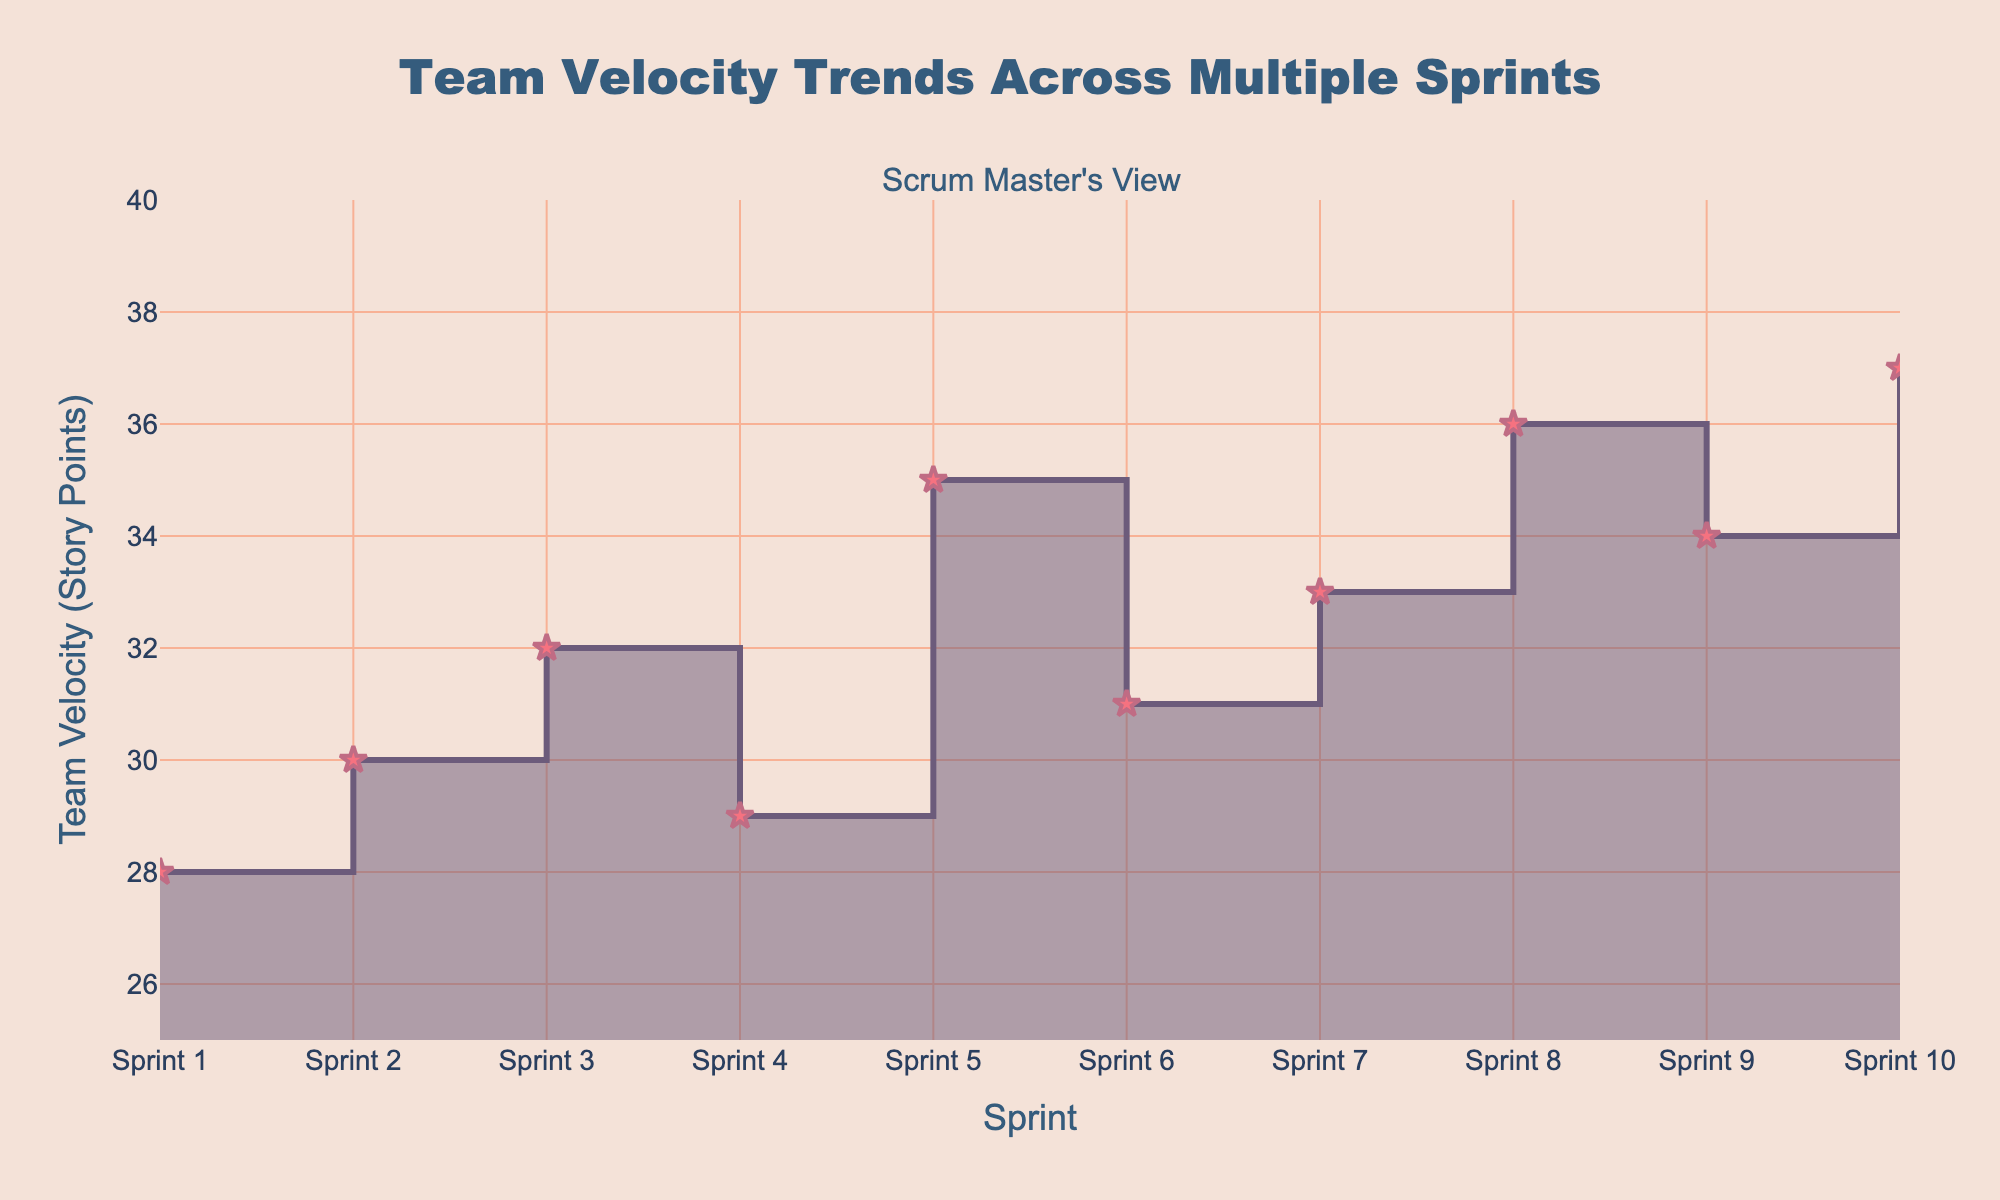What is the title of the step area chart? The title of a chart is usually located at the top and gives a concise description of the chart's content. Here, the title "Team Velocity Trends Across Multiple Sprints" is displayed prominently.
Answer: Team Velocity Trends Across Multiple Sprints What is the range of the y-axis on the chart? The y-axis range is displayed alongside the axis and indicates the scope of values plotted on this axis. Here, it ranges from 25 to 40 story points.
Answer: 25 to 40 How many sprints are included in this step area chart? Each data point represents a sprint, and we can count these points along the x-axis to determine the total number. There are 10 sprints from Sprint 1 to Sprint 10.
Answer: 10 Which sprint has the highest team velocity recorded? To find the highest velocity, look at the peaks of the chart. Sprint 10 has the highest point at 37 story points.
Answer: Sprint 10 Which sprints have a team velocity of 35 story points or more? By examining the chart, identify the segments where the velocity reaches or exceeds 35 story points. These occur at Sprints 5, 8, 9, and 10.
Answer: Sprints 5, 8, 9, 10 What is the difference in team velocity between Sprint 5 and Sprint 6? The velocities are plotted along the y-axis. Sprint 5 has 35 story points and Sprint 6 has 31 story points. The difference is 35 - 31 = 4 story points.
Answer: 4 story points What is the average team velocity across all sprints? Add the velocities of all sprints and divide by the number of sprints. The sum is 28 + 30 + 32 + 29 + 35 + 31 + 33 + 36 + 34 + 37 = 325. The average is 325/10 = 32.5 story points.
Answer: 32.5 story points Between which consecutive sprints does the team velocity increase the most? By checking the differences between consecutive velocities, the largest increase is between Sprint 4 (29 points) and Sprint 5 (35 points), an increase of 6 story points.
Answer: Between Sprints 4 and 5 What trend do you observe in the team velocity across sprints? The chart shows a general upward trend with fluctuations. The velocity increases over time with minor decreases in some sprints.
Answer: Upward trend with fluctuations Which sprint shows the largest drop in team velocity compared to its previous sprint? The largest drop can be determined by looking at the decreases between consecutive sprints. The largest drop is from Sprint 5 (35 story points) to Sprint 6 (31 story points), decreasing by 4 points.
Answer: Sprint 6 